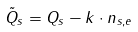Convert formula to latex. <formula><loc_0><loc_0><loc_500><loc_500>\tilde { Q } _ { s } = Q _ { s } - k \cdot n _ { s , e }</formula> 